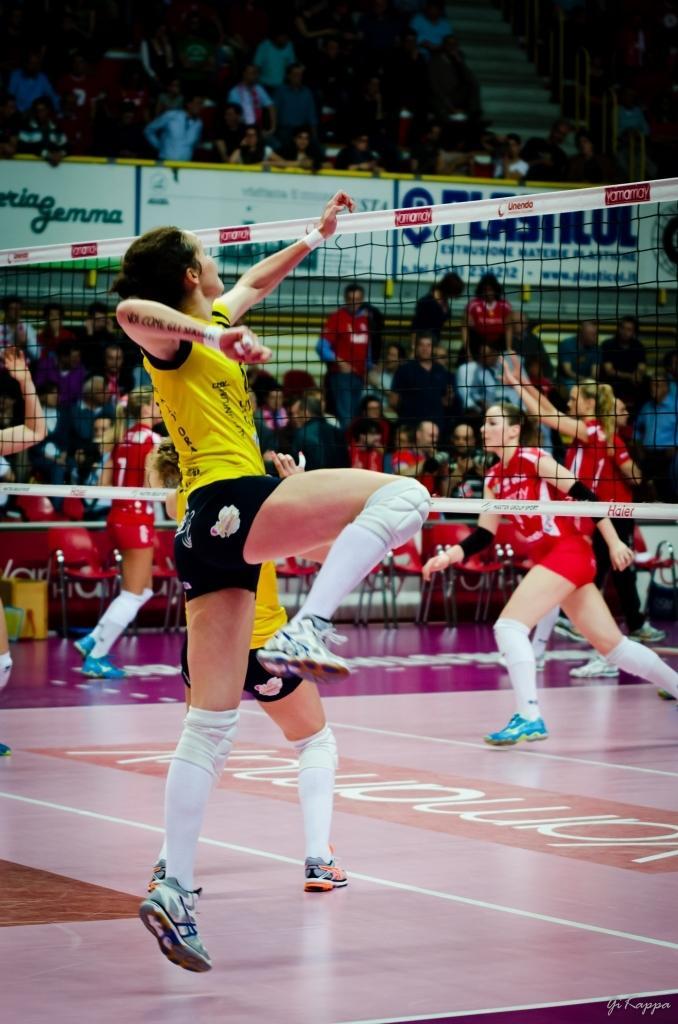Can you describe this image briefly? In the middle of the image a person is jumping. In front of him there is net. Behind the net few people are standing and sitting in the stadium. 